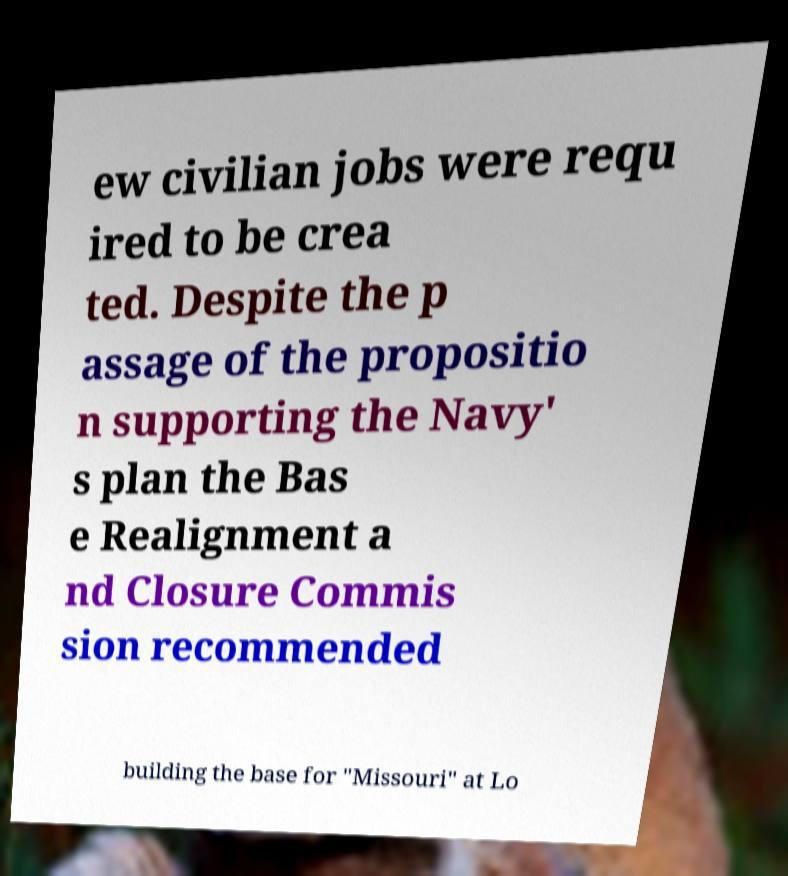For documentation purposes, I need the text within this image transcribed. Could you provide that? ew civilian jobs were requ ired to be crea ted. Despite the p assage of the propositio n supporting the Navy' s plan the Bas e Realignment a nd Closure Commis sion recommended building the base for "Missouri" at Lo 